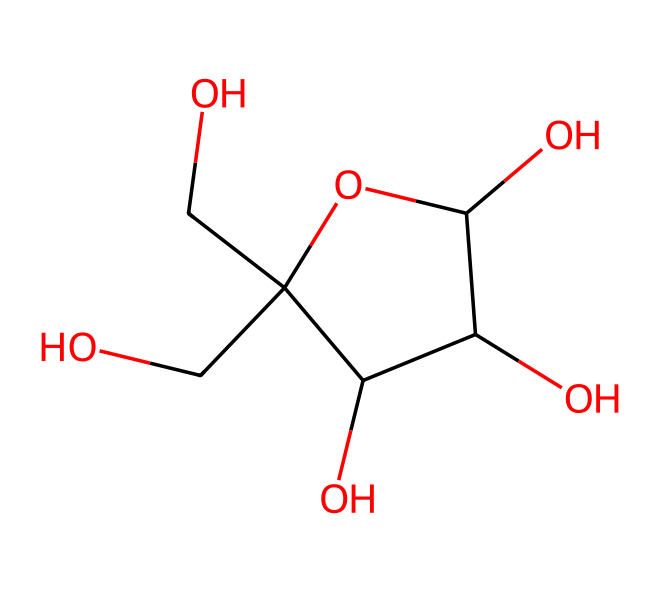how many carbon atoms are in the structure? By examining the SMILES representation, we count the carbon atoms denoted by "C". There are a total of 6 carbon atoms in the structure.
Answer: 6 how many oxygen atoms are in the structure? In the provided SMILES, the oxygen atoms are represented by "O". Counting these in the structure, we find there are 6 oxygen atoms.
Answer: 6 what is the molecular formula of this compound? The molecular formula is determined by the total number of each type of atom present in the structure: C:6, H:12, O:6. Therefore, the molecular formula is C6H12O6.
Answer: C6H12O6 what is the type of carbohydrate represented by this structure? Given the structure and the number of carbon, hydrogen, and oxygen atoms, this compound is a monosaccharide because it cannot be hydrolyzed into simpler sugars.
Answer: monosaccharide how does this carbohydrate support athlete recovery? As a simple sugar, fructose can be rapidly absorbed and utilized by the body to replenish glycogen stores, particularly after intense exercise, aiding recovery.
Answer: replenishes glycogen what functional groups are present in this carbohydrate? In the structure, we observe multiple hydroxyl (–OH) groups, which classify this carbohydrate as an alcohol. These functional groups contribute to its solubility and reactivity.
Answer: hydroxyl groups is this compound an aldose or a ketose? The structure shows that the carbonyl (C=O) group is located at the second carbon, indicating that this carbohydrate is classified as a ketose.
Answer: ketose 